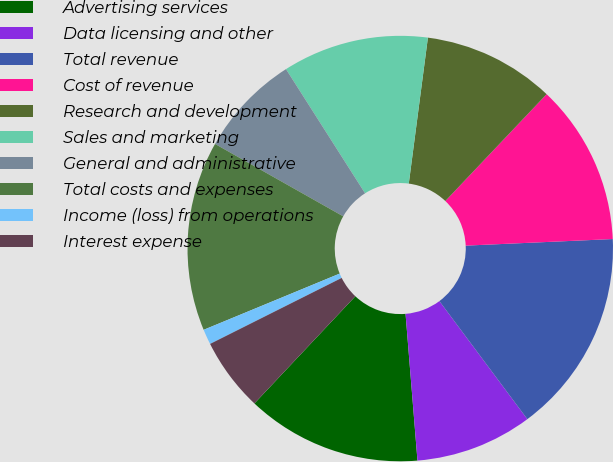<chart> <loc_0><loc_0><loc_500><loc_500><pie_chart><fcel>Advertising services<fcel>Data licensing and other<fcel>Total revenue<fcel>Cost of revenue<fcel>Research and development<fcel>Sales and marketing<fcel>General and administrative<fcel>Total costs and expenses<fcel>Income (loss) from operations<fcel>Interest expense<nl><fcel>13.31%<fcel>8.9%<fcel>15.52%<fcel>12.21%<fcel>10.0%<fcel>11.1%<fcel>7.79%<fcel>14.42%<fcel>1.16%<fcel>5.58%<nl></chart> 